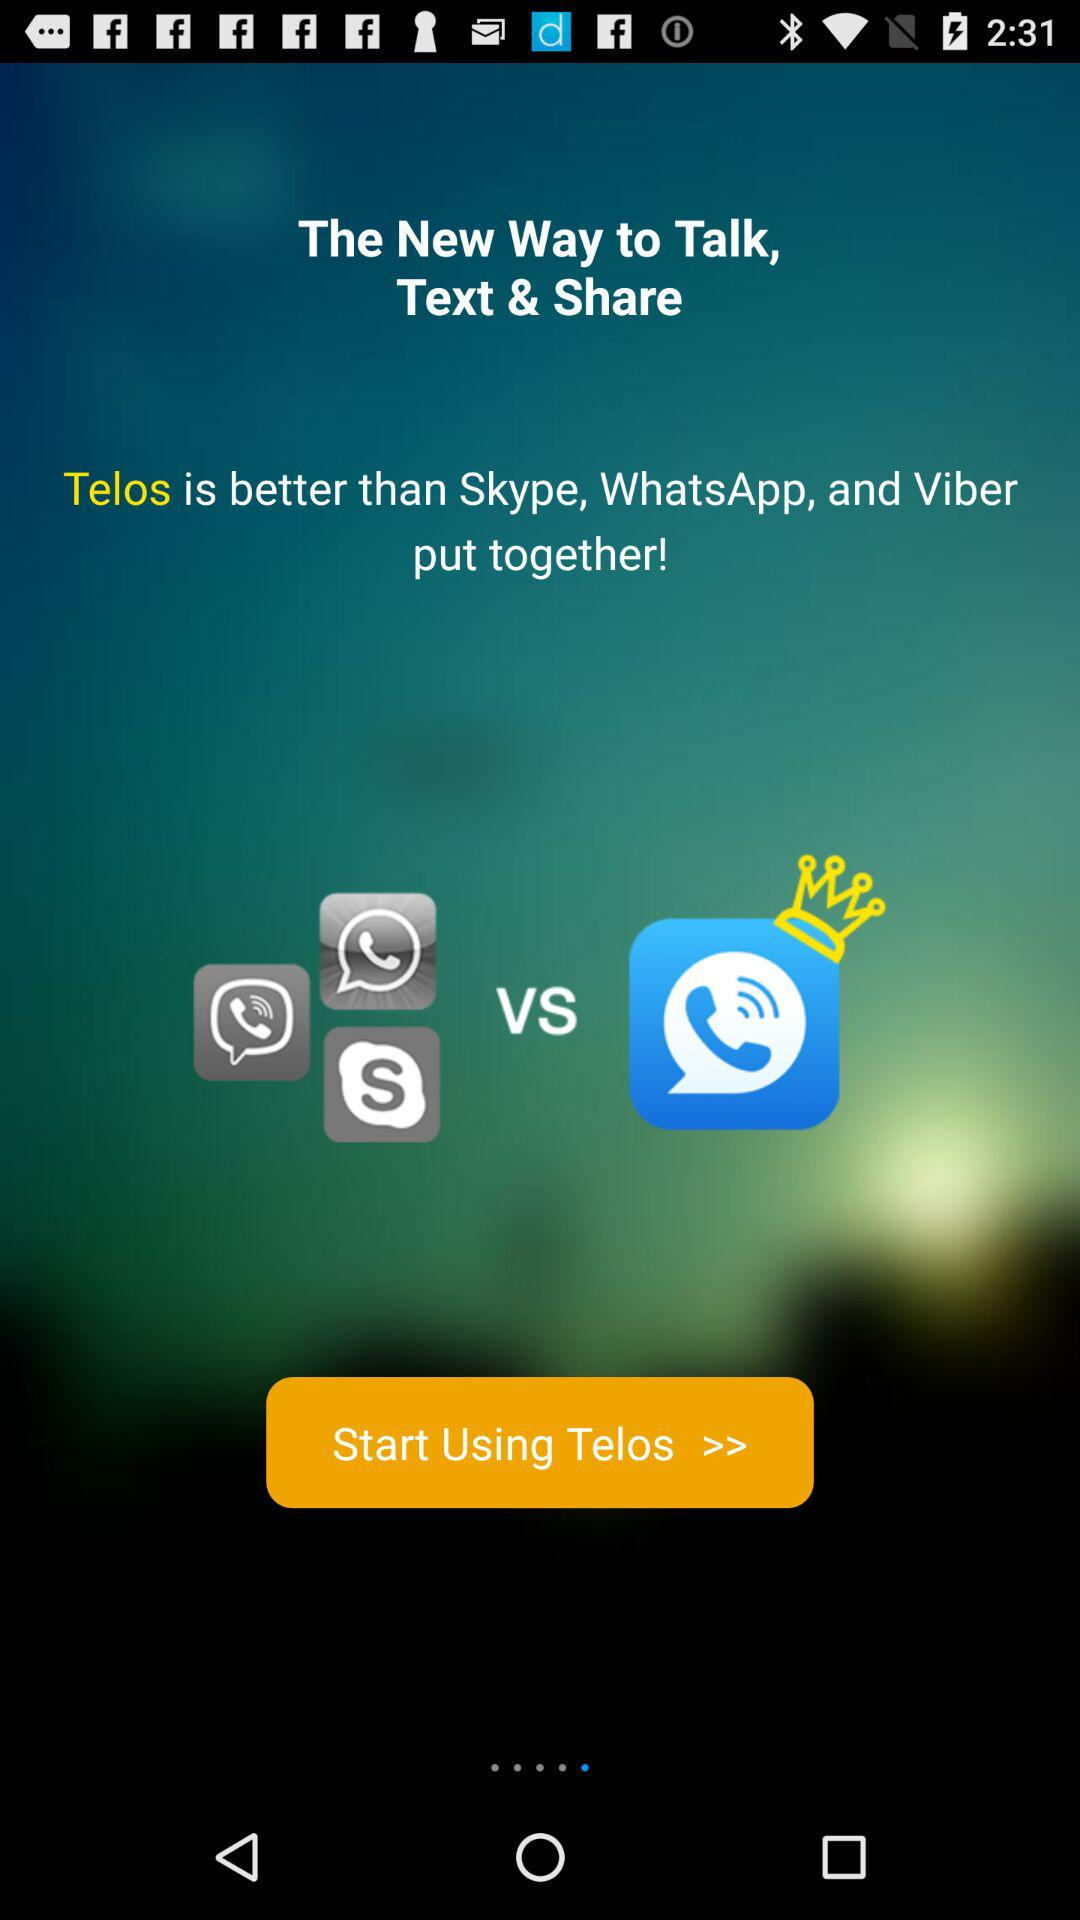What is the application name? The application name is "Telos". 